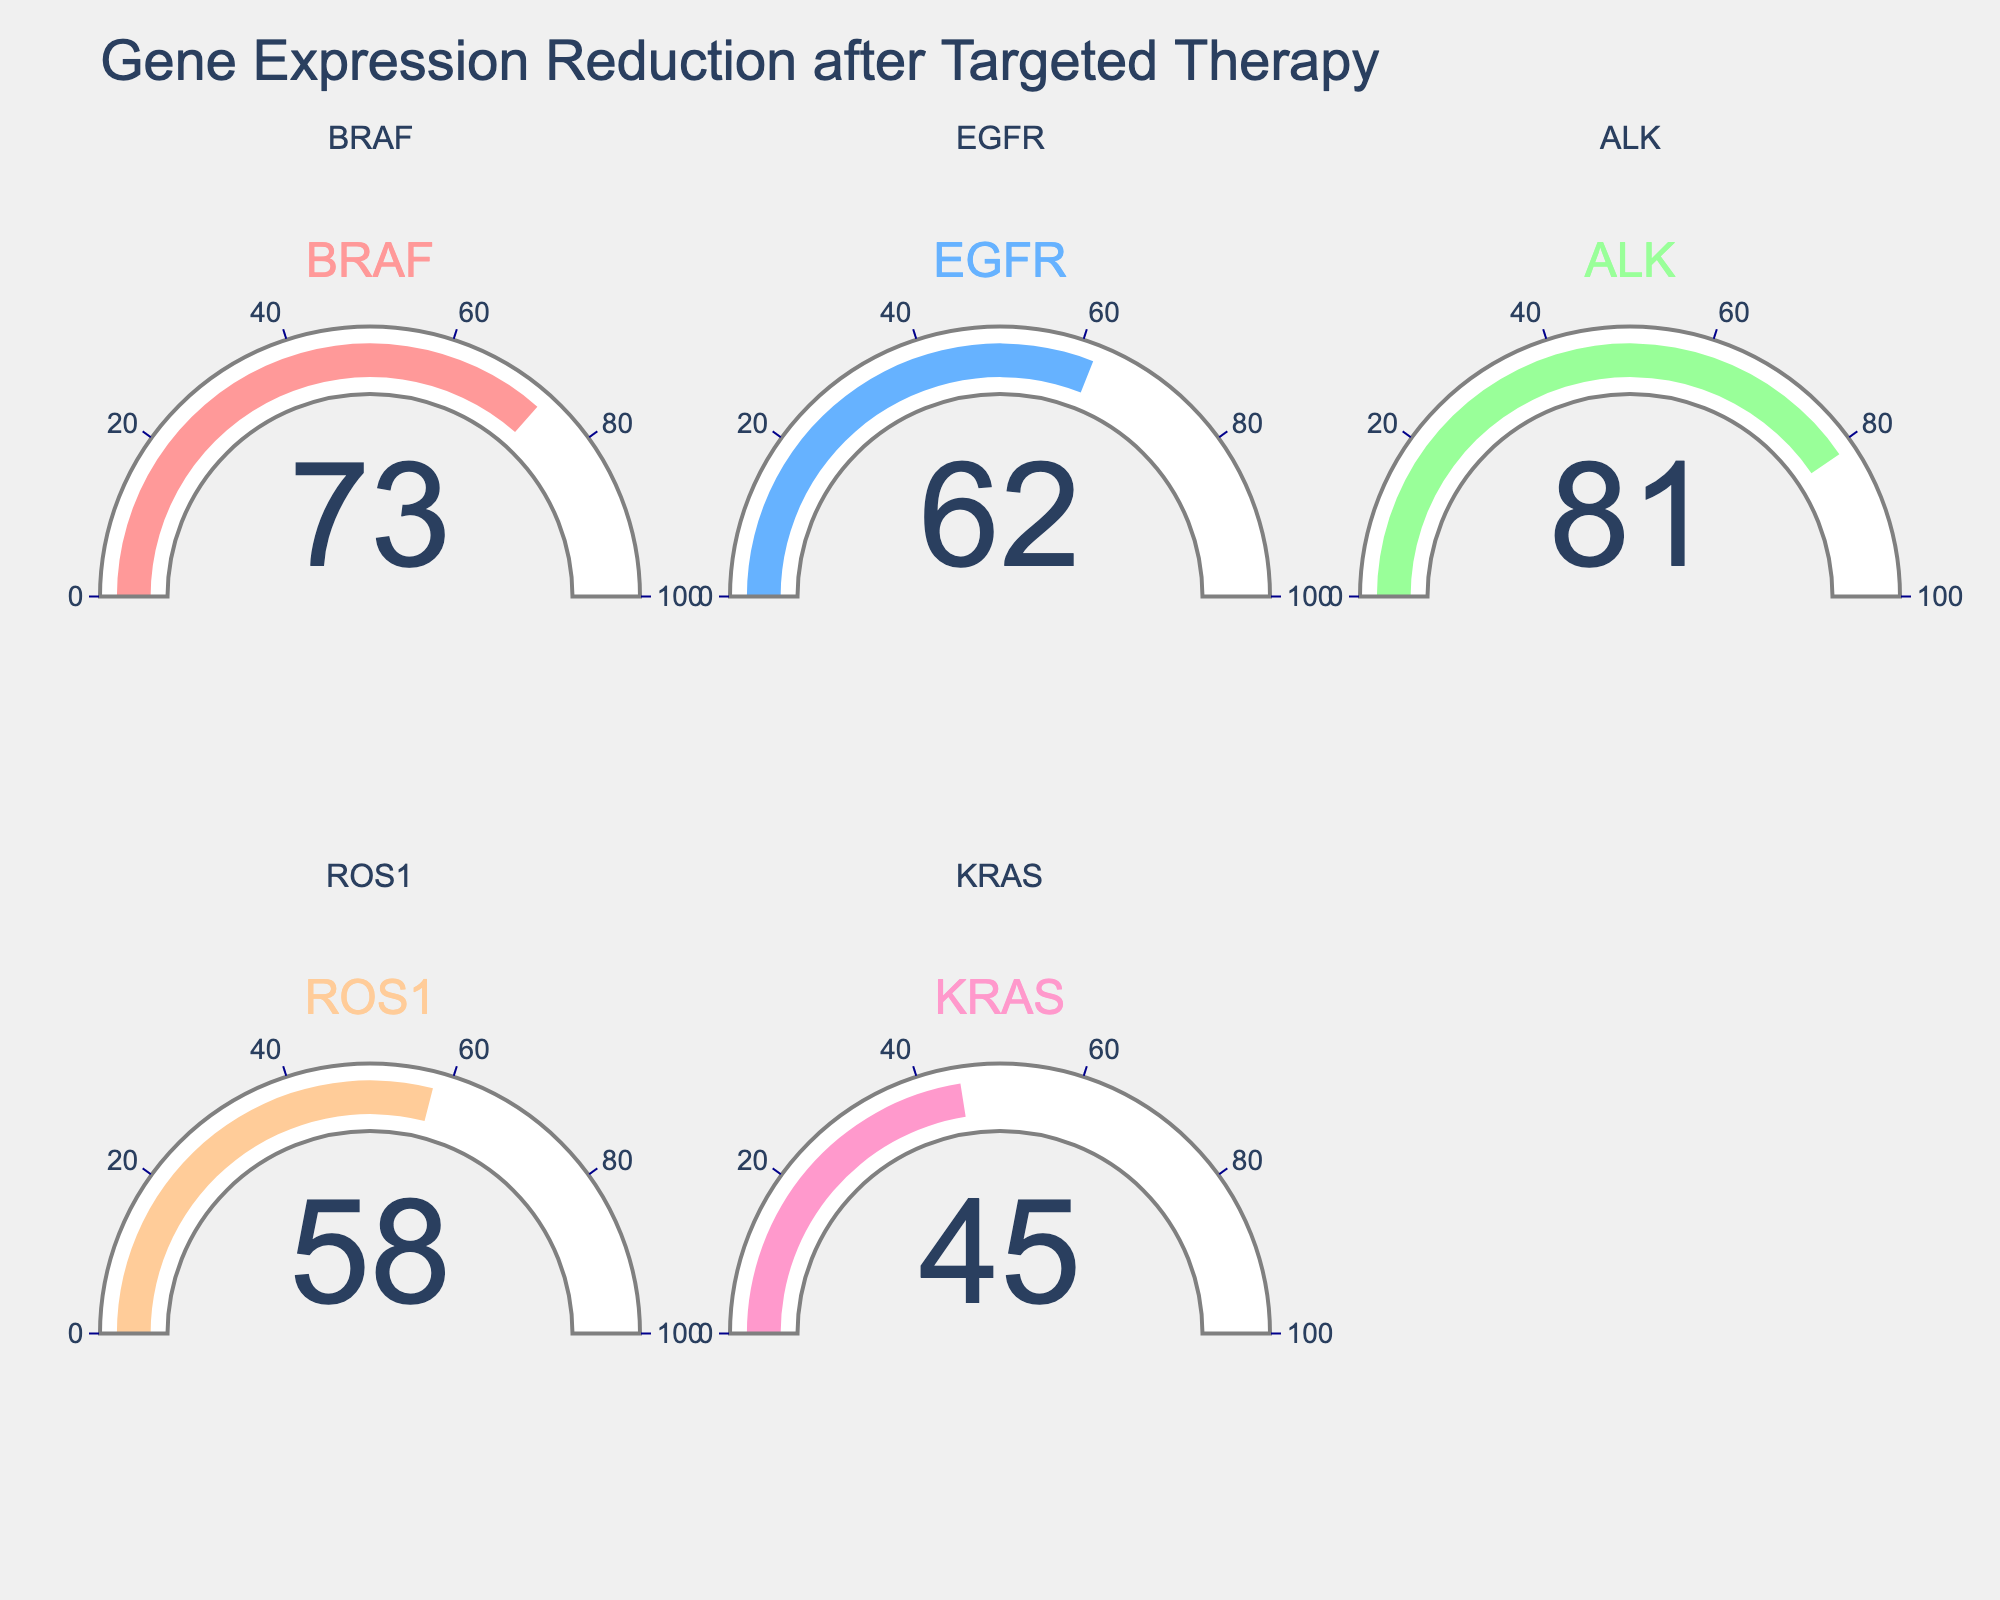Which gene shows the highest percentage of gene expression reduction? To find the highest percentage, look for the largest value displayed on any of the gauges. BRAF has 73%, EGFR has 62%, ALK has 81%, ROS1 has 58%, and KRAS has 45%. The highest value is 81% for ALK.
Answer: ALK Which gene shows the lowest percentage of gene expression reduction? To find the lowest percentage, look for the smallest value displayed on any of the gauges. BRAF has 73%, EGFR has 62%, ALK has 81%, ROS1 has 58%, and KRAS has 45%. The lowest value is 45% for KRAS.
Answer: KRAS What is the average reduction percentage across all genes? To calculate the average, add up all the percentages and divide by the number of genes. (73 + 62 + 81 + 58 + 45) = 319. Then, 319 / 5 = 63.8.
Answer: 63.8 Is there any gene with a reduction percentage greater than 75%? Look at each gauge and identify if any value exceeds 75%. ALK has 81%, which is greater than 75%.
Answer: Yes, ALK 